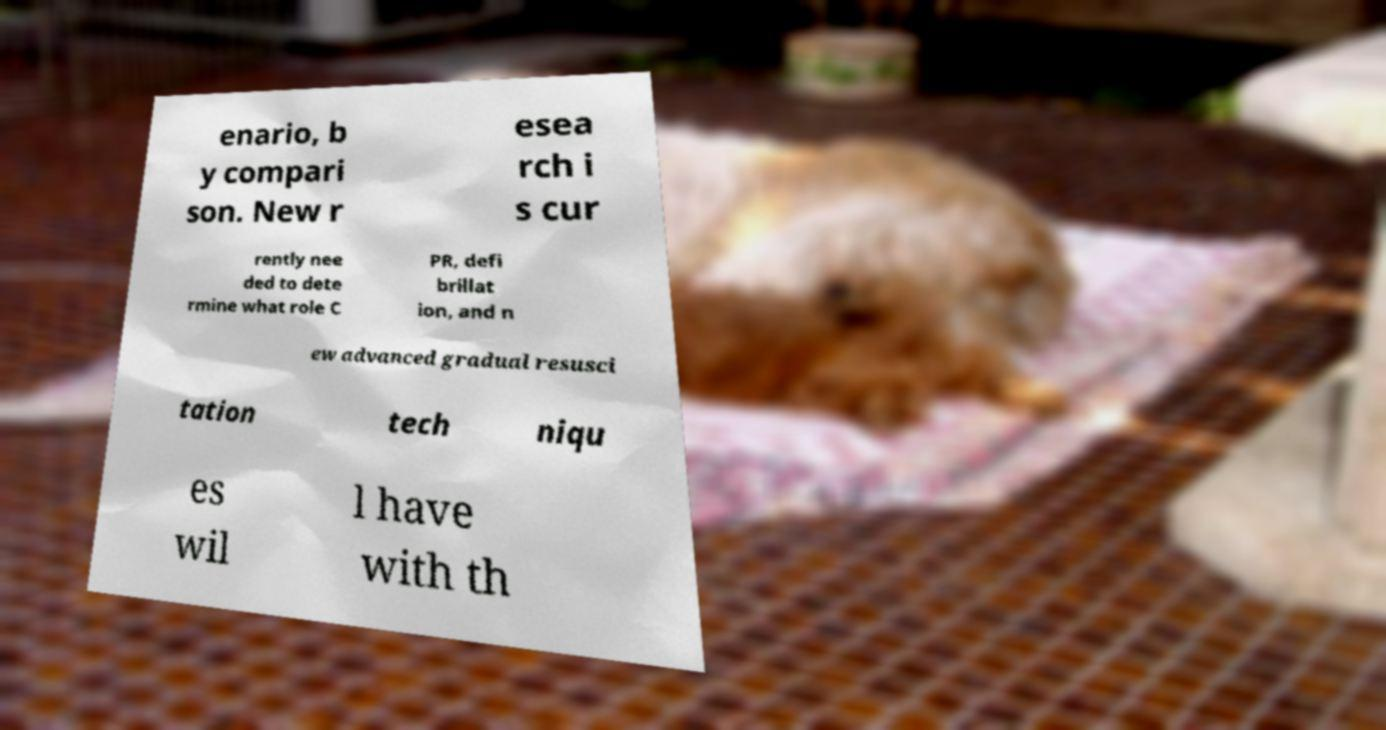There's text embedded in this image that I need extracted. Can you transcribe it verbatim? enario, b y compari son. New r esea rch i s cur rently nee ded to dete rmine what role C PR, defi brillat ion, and n ew advanced gradual resusci tation tech niqu es wil l have with th 